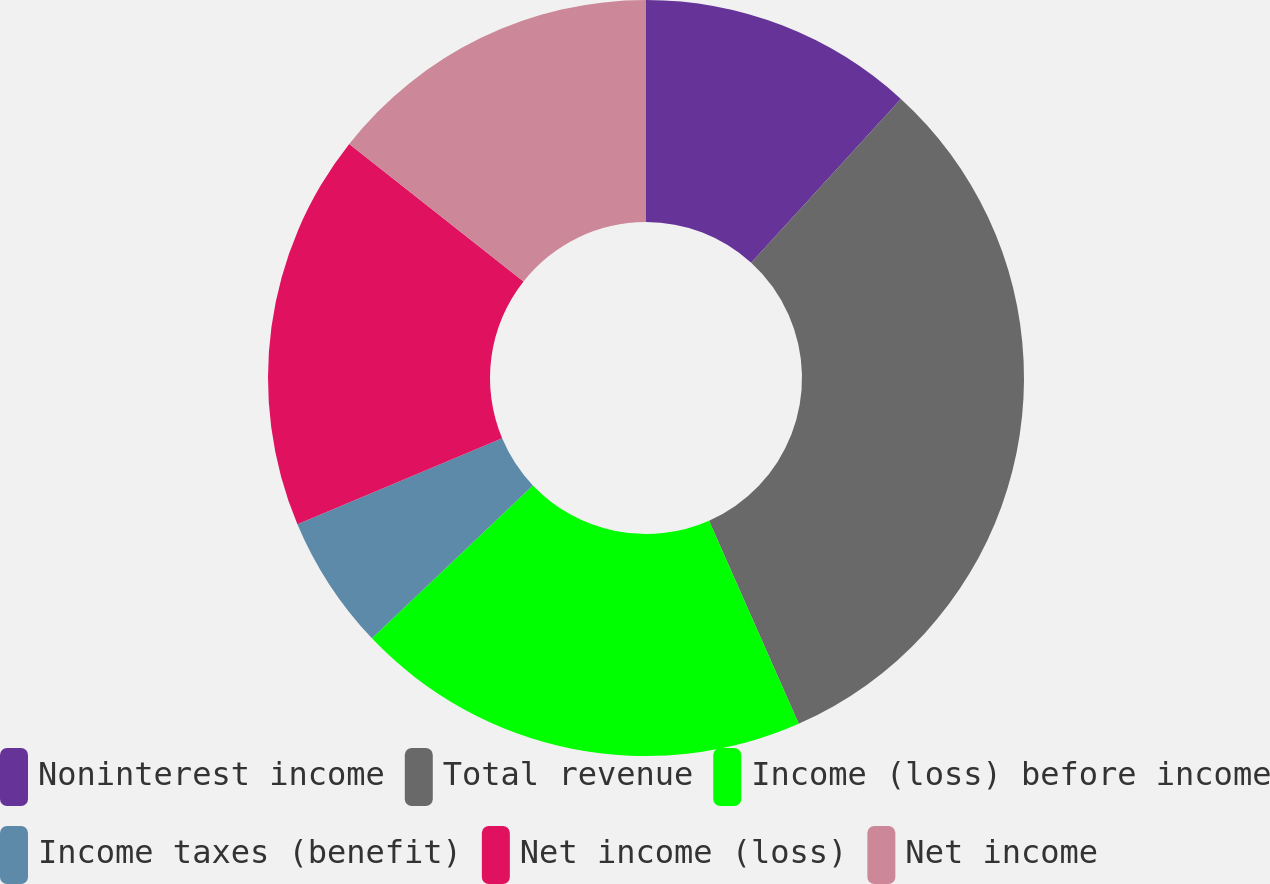Convert chart to OTSL. <chart><loc_0><loc_0><loc_500><loc_500><pie_chart><fcel>Noninterest income<fcel>Total revenue<fcel>Income (loss) before income<fcel>Income taxes (benefit)<fcel>Net income (loss)<fcel>Net income<nl><fcel>11.78%<fcel>31.6%<fcel>19.53%<fcel>5.77%<fcel>16.95%<fcel>14.37%<nl></chart> 